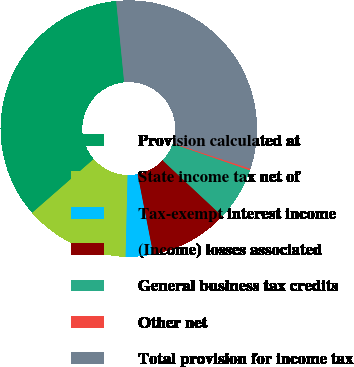Convert chart to OTSL. <chart><loc_0><loc_0><loc_500><loc_500><pie_chart><fcel>Provision calculated at<fcel>State income tax net of<fcel>Tax-exempt interest income<fcel>(Income) losses associated<fcel>General business tax credits<fcel>Other net<fcel>Total provision for income tax<nl><fcel>34.87%<fcel>13.19%<fcel>3.46%<fcel>9.95%<fcel>6.7%<fcel>0.21%<fcel>31.62%<nl></chart> 